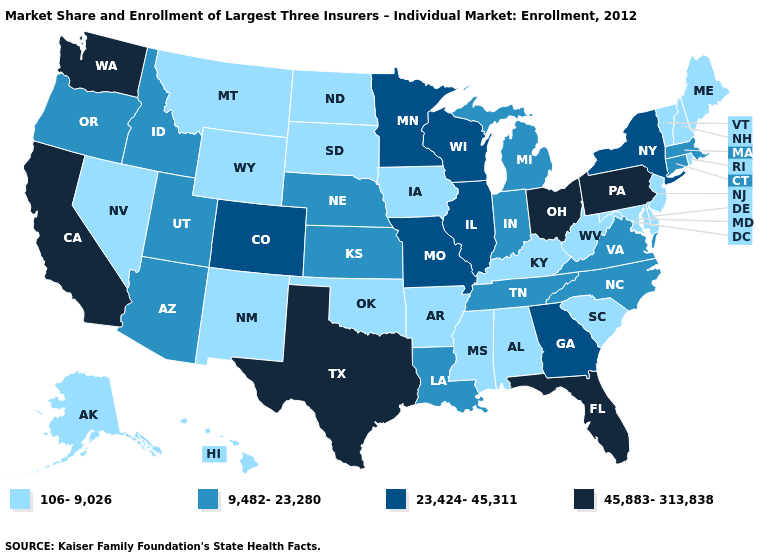What is the value of Arkansas?
Concise answer only. 106-9,026. Name the states that have a value in the range 23,424-45,311?
Concise answer only. Colorado, Georgia, Illinois, Minnesota, Missouri, New York, Wisconsin. Does Massachusetts have a lower value than Illinois?
Be succinct. Yes. Which states have the highest value in the USA?
Write a very short answer. California, Florida, Ohio, Pennsylvania, Texas, Washington. Among the states that border Utah , which have the highest value?
Concise answer only. Colorado. What is the value of Indiana?
Short answer required. 9,482-23,280. What is the value of Hawaii?
Keep it brief. 106-9,026. Among the states that border Wyoming , does Colorado have the lowest value?
Short answer required. No. Among the states that border California , which have the lowest value?
Keep it brief. Nevada. Does Oklahoma have the same value as Alaska?
Give a very brief answer. Yes. Name the states that have a value in the range 106-9,026?
Be succinct. Alabama, Alaska, Arkansas, Delaware, Hawaii, Iowa, Kentucky, Maine, Maryland, Mississippi, Montana, Nevada, New Hampshire, New Jersey, New Mexico, North Dakota, Oklahoma, Rhode Island, South Carolina, South Dakota, Vermont, West Virginia, Wyoming. Does Virginia have the lowest value in the South?
Short answer required. No. Name the states that have a value in the range 45,883-313,838?
Short answer required. California, Florida, Ohio, Pennsylvania, Texas, Washington. Does Connecticut have the lowest value in the Northeast?
Concise answer only. No. Does Alabama have a lower value than North Carolina?
Concise answer only. Yes. 